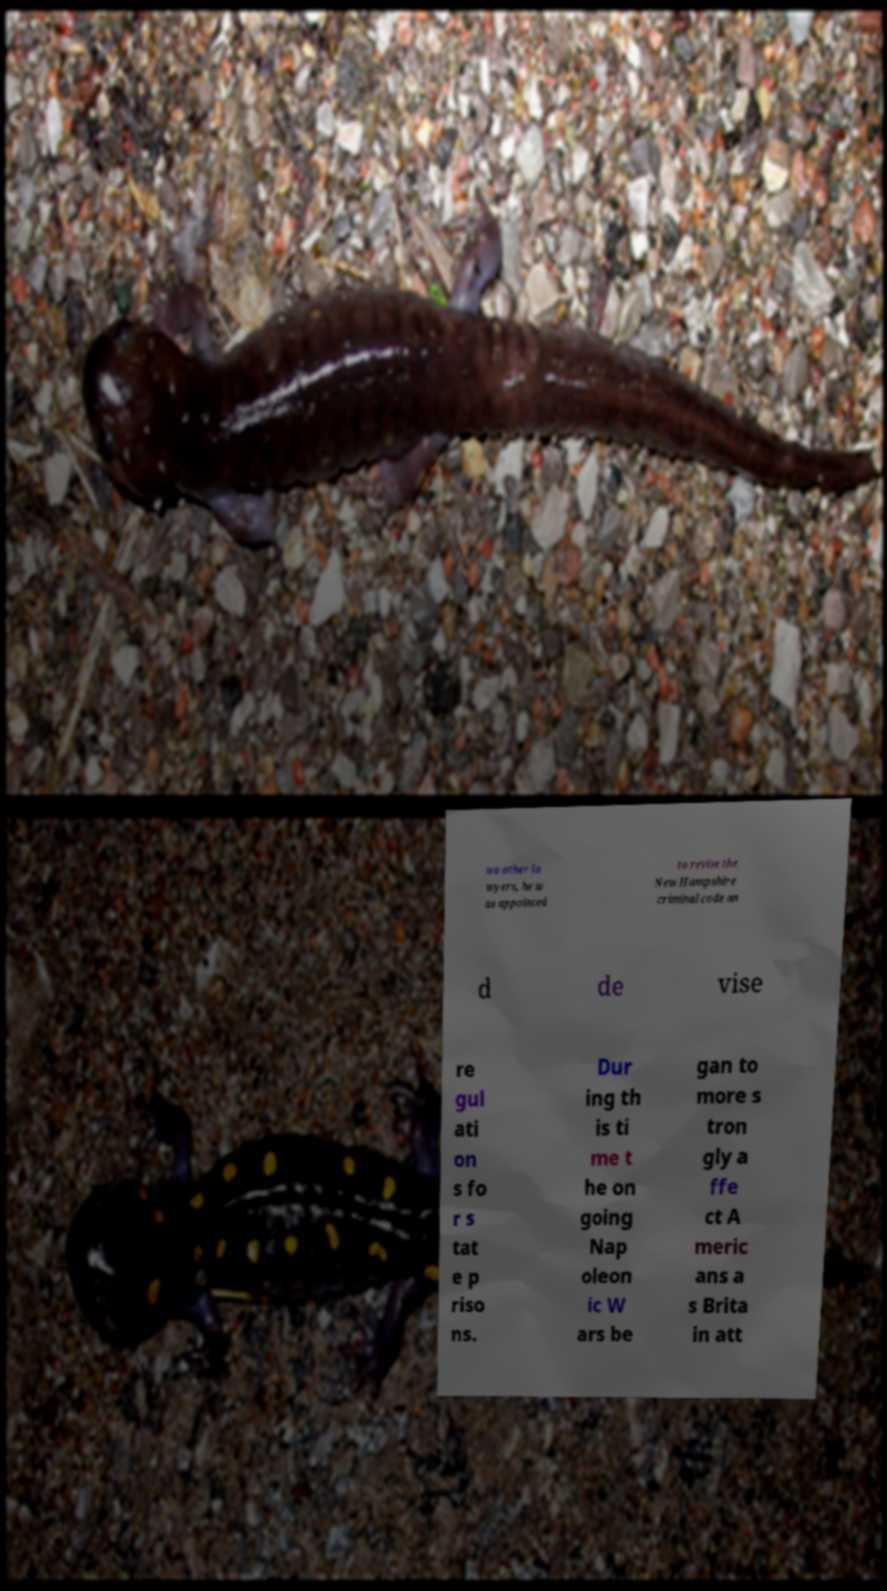Could you assist in decoding the text presented in this image and type it out clearly? wo other la wyers, he w as appointed to revise the New Hampshire criminal code an d de vise re gul ati on s fo r s tat e p riso ns. Dur ing th is ti me t he on going Nap oleon ic W ars be gan to more s tron gly a ffe ct A meric ans a s Brita in att 